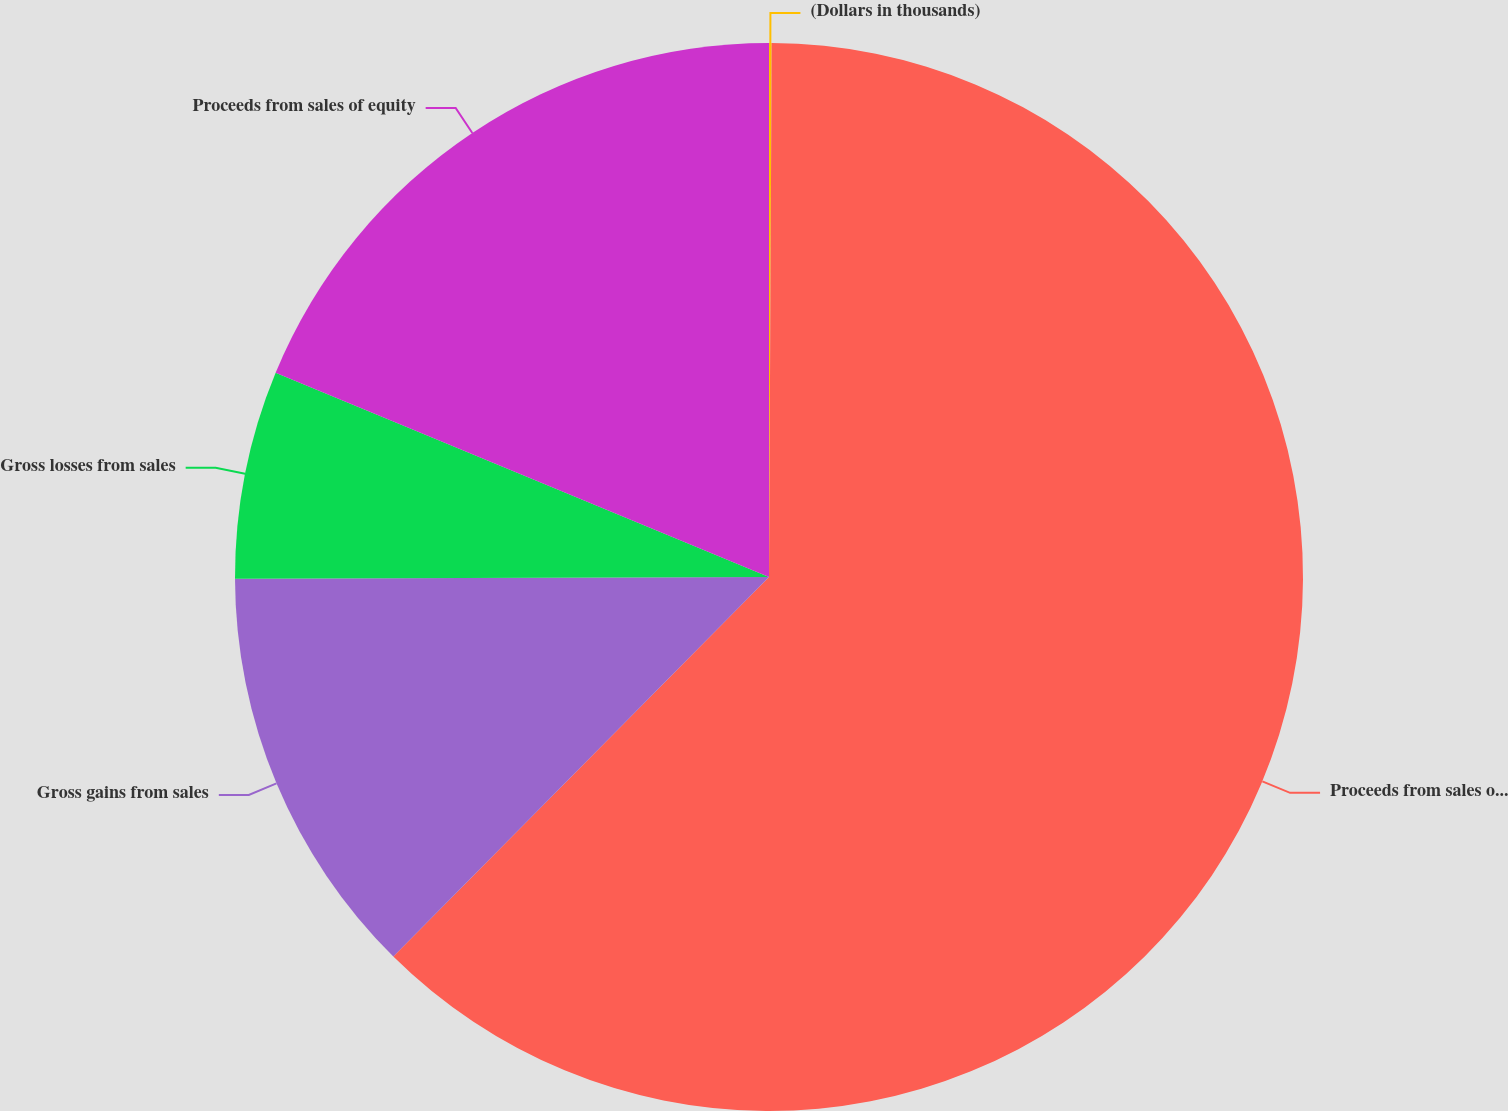Convert chart. <chart><loc_0><loc_0><loc_500><loc_500><pie_chart><fcel>(Dollars in thousands)<fcel>Proceeds from sales of fixed<fcel>Gross gains from sales<fcel>Gross losses from sales<fcel>Proceeds from sales of equity<nl><fcel>0.08%<fcel>62.34%<fcel>12.53%<fcel>6.3%<fcel>18.75%<nl></chart> 